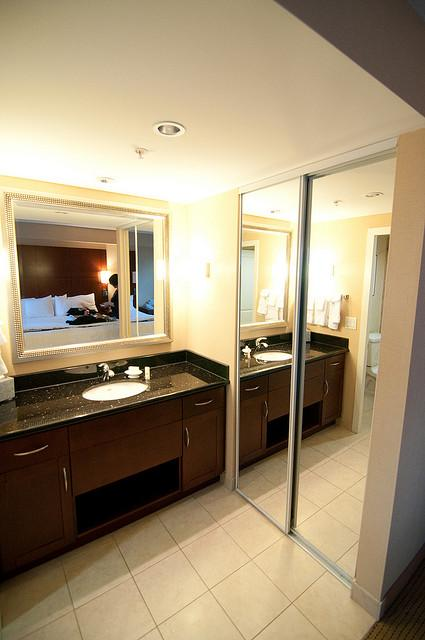What is behind the two tall mirrors?

Choices:
A) bathroom
B) bedroom
C) closet
D) hallway closet 